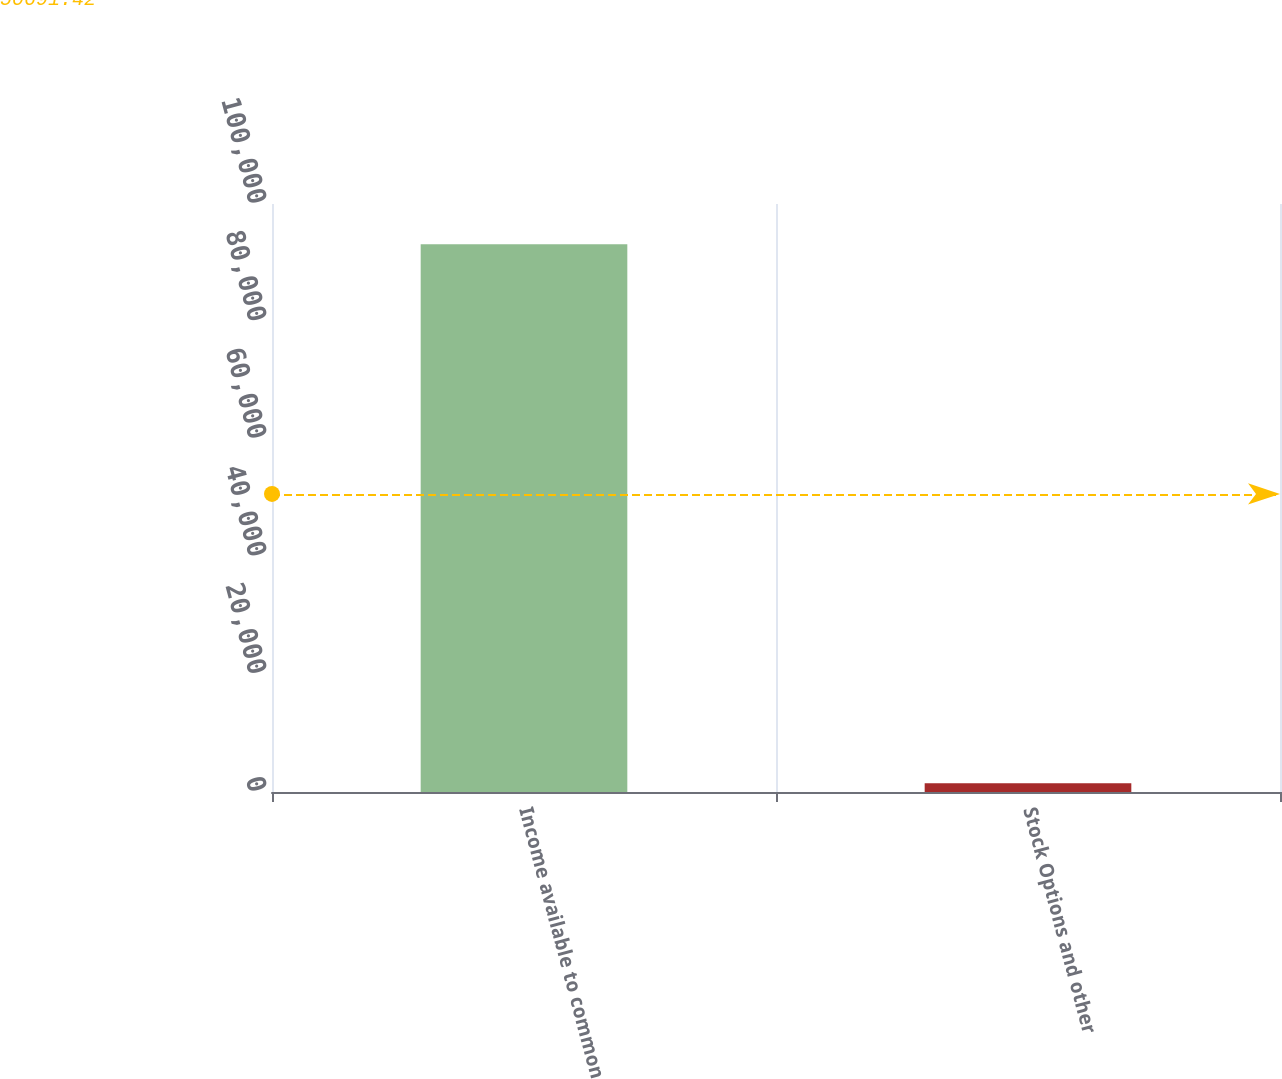Convert chart. <chart><loc_0><loc_0><loc_500><loc_500><bar_chart><fcel>Income available to common<fcel>Stock Options and other<nl><fcel>93145<fcel>1467<nl></chart> 